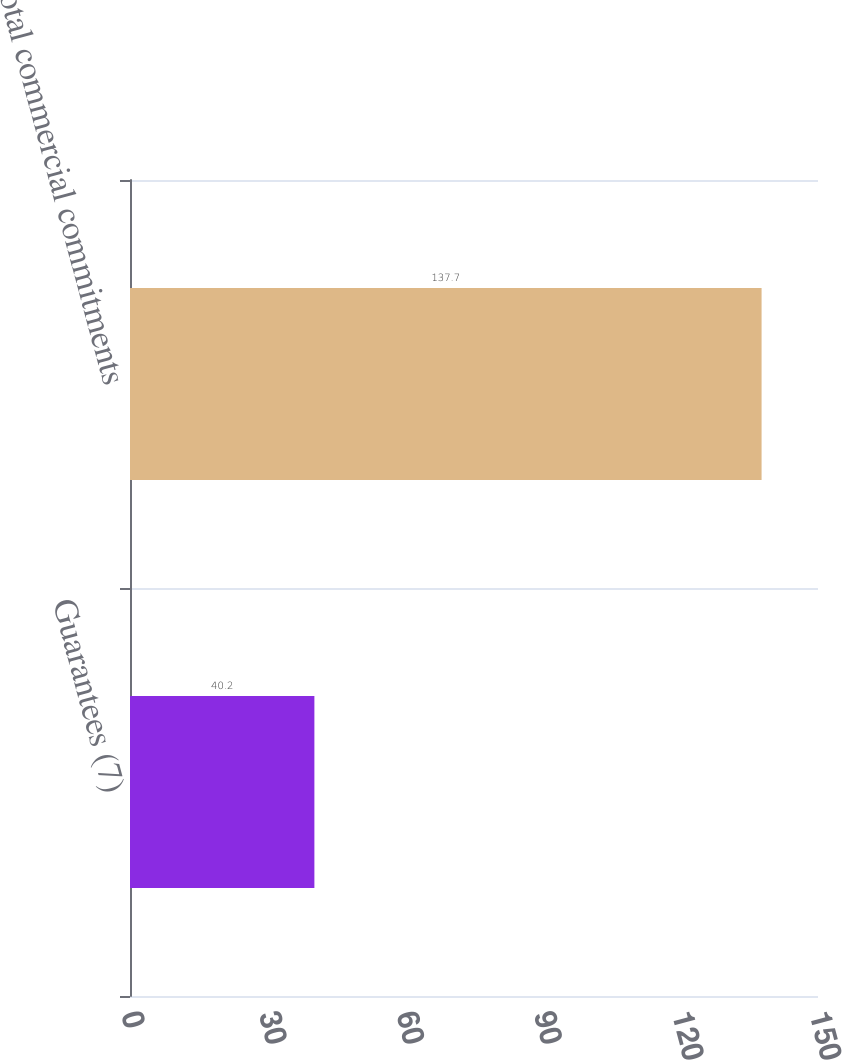<chart> <loc_0><loc_0><loc_500><loc_500><bar_chart><fcel>Guarantees (7)<fcel>Total commercial commitments<nl><fcel>40.2<fcel>137.7<nl></chart> 